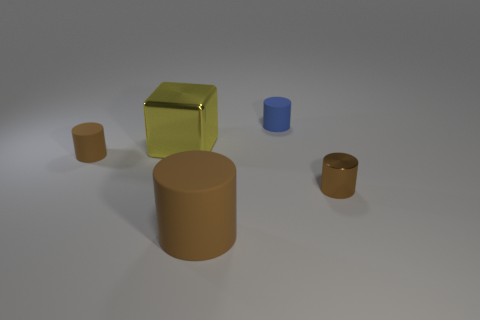Subtract all cyan cubes. How many brown cylinders are left? 3 Add 1 tiny blue cylinders. How many objects exist? 6 Subtract all cylinders. How many objects are left? 1 Add 4 green metallic cubes. How many green metallic cubes exist? 4 Subtract 0 gray cylinders. How many objects are left? 5 Subtract all purple shiny cylinders. Subtract all metallic cylinders. How many objects are left? 4 Add 5 blue rubber cylinders. How many blue rubber cylinders are left? 6 